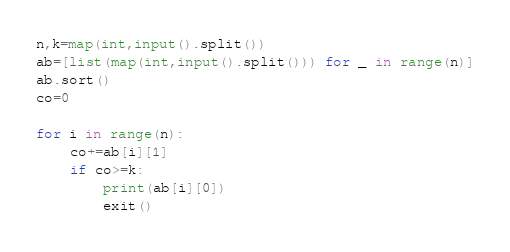<code> <loc_0><loc_0><loc_500><loc_500><_Python_>n,k=map(int,input().split())
ab=[list(map(int,input().split())) for _ in range(n)]
ab.sort()
co=0

for i in range(n):
    co+=ab[i][1]
    if co>=k:
        print(ab[i][0])
        exit()
</code> 